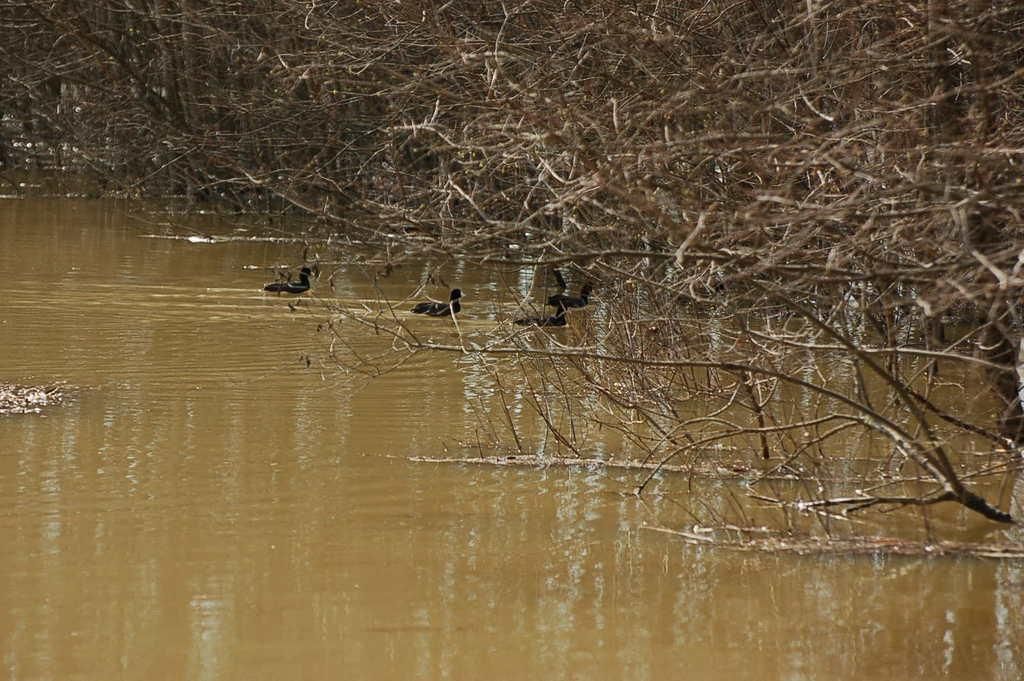What type of animals can be seen in the image? There are ducks in the water in the image. What can be seen on the right side of the image? There are branches of trees on the right side of the image. What is visible in the background of the image? There are trees visible in the background of the image. What type of horn can be seen on the ducks in the image? There are no horns present on the ducks in the image. 